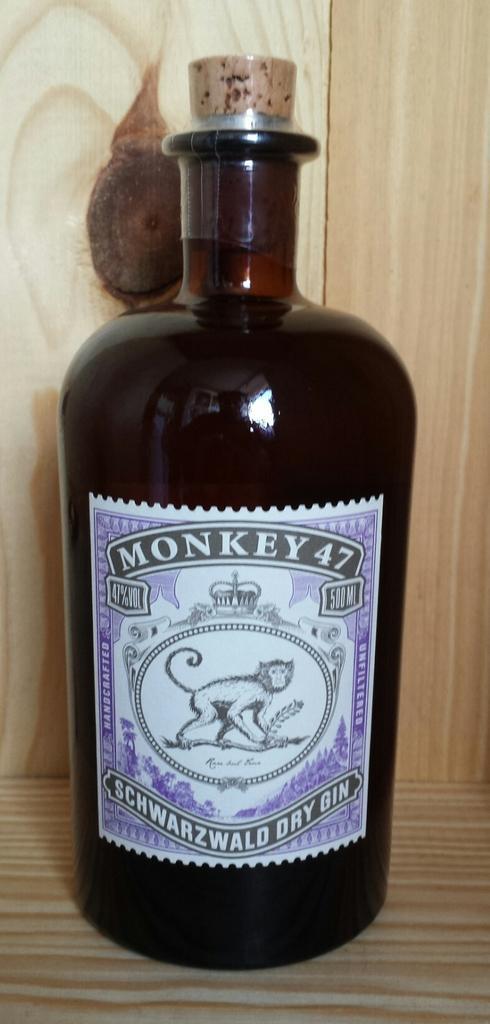Please provide a concise description of this image. Here we see a bottle of gin on the table. 